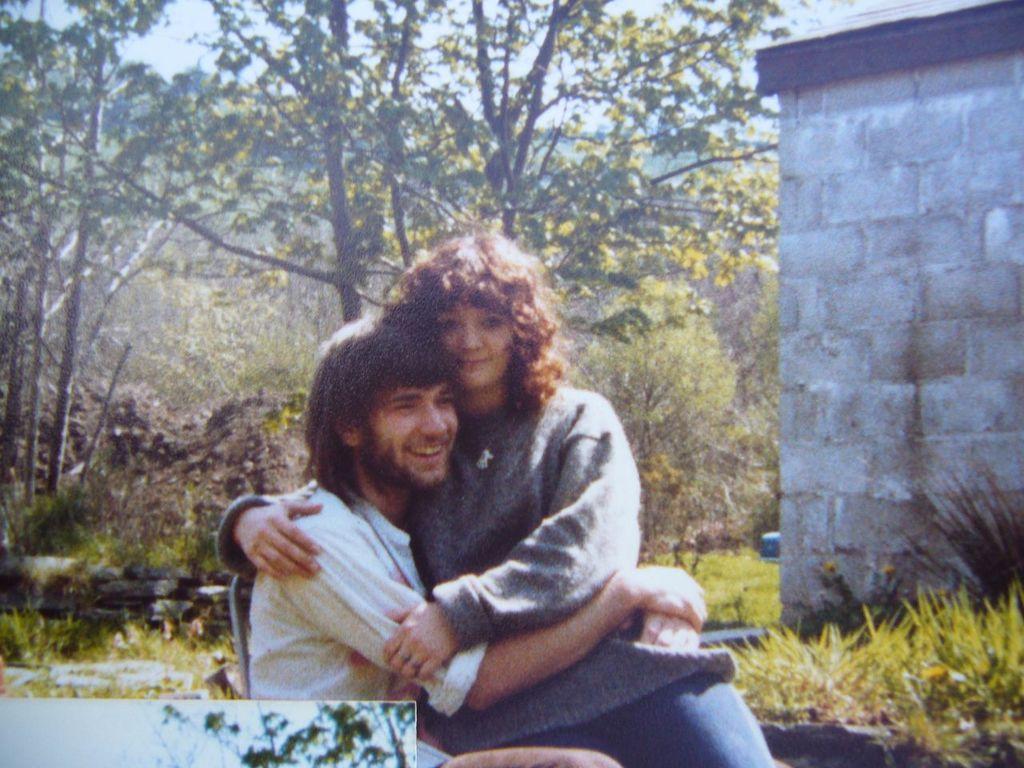Please provide a concise description of this image. In the front of the image I can see two people. Man is sitting on the chair and woman is sitting on a man. In the background of the image there is a wall, trees and grass. Through trees sky is visible.   